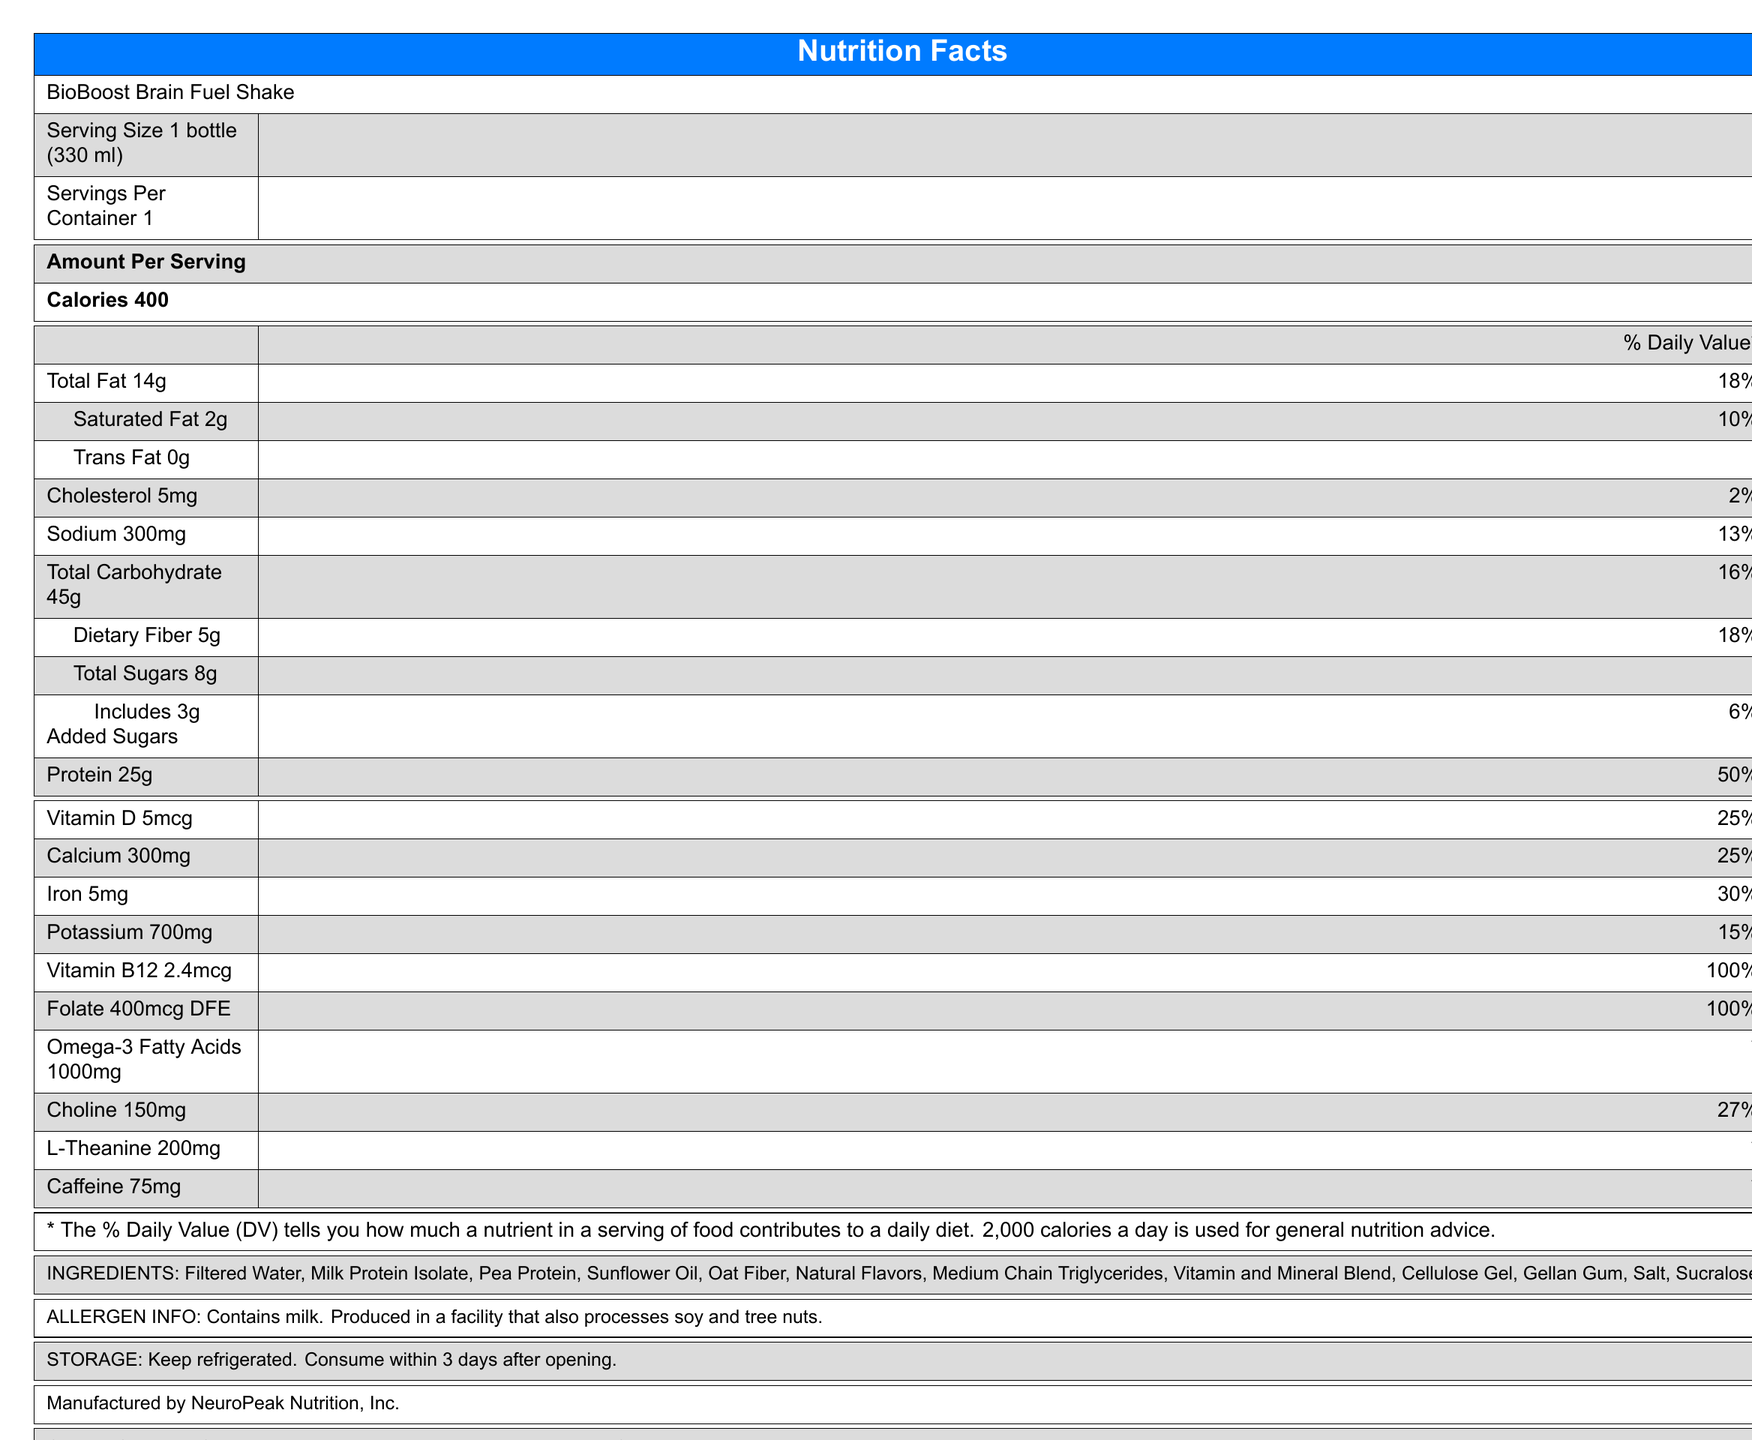what is the serving size of the BioBoost Brain Fuel Shake? The serving size is explicitly stated as "1 bottle (330 ml)" in the document.
Answer: 1 bottle (330 ml) how many calories are there per serving? The document lists the calories per serving as 400.
Answer: 400 what percentage of the daily value of protein does one serving provide? The document shows that one serving provides 25g of protein, which is 50% of the daily value.
Answer: 50% how much total carbohydrate is in one serving of the shake? The total carbohydrate per serving is listed as 45g in the document.
Answer: 45g what vitamins and minerals are provided at 100% daily value in one serving? Both Vitamin B12 and Folate are listed at 100% of the daily value for each serving.
Answer: Vitamin B12 and Folate how much sodium does one serving contain? The document states the sodium content as 300mg per serving.
Answer: 300mg how much added sugar is included in one serving of the shake? The document indicates that the shake includes 3g of added sugars per serving.
Answer: 3g which ingredient is listed first in the ingredient list? The first ingredient listed for the shake is Filtered Water.
Answer: Filtered Water where is the BioBoost Brain Fuel Shake manufactured? a) NeuroPeak Nutrition, Inc. b) BioBoost Nutrition, Inc. c) BrainFuel Co. The document specifies that the shake is manufactured by NeuroPeak Nutrition, Inc.
Answer: a) NeuroPeak Nutrition, Inc. how many grams of dietary fiber are in each serving? The dietary fiber content per serving is listed as 5g in the document.
Answer: 5g what percentage of the daily value of choline does one serving provide? The document states that one serving provides 150mg of choline, which is 27% of the daily value.
Answer: 27% does the BioBoost Brain Fuel Shake contain any allergens? The document notes that the shake contains milk and is produced in a facility that also processes soy and tree nuts.
Answer: Yes is the shake free of trans fats? The document lists the trans fat content as 0g, indicating that it is trans fat-free.
Answer: Yes how should the shake be stored once opened? The storage instructions specified in the document are to keep the shake refrigerated and consume it within 3 days after opening.
Answer: Keep refrigerated. Consume within 3 days after opening. does the shake provide omega-3 fatty acids? The document lists 1000mg of omega-3 fatty acids per serving.
Answer: Yes how much caffeine does each serving contain? The caffeine content per serving is listed as 75mg in the document.
Answer: 75mg which ingredient is not listed in the nutrition facts label but is mentioned in the additional information section? The document doesn't provide any additional ingredients beyond those already listed.
Answer: This cannot be determined. describe the main purpose of the BioBoost Brain Fuel Shake as stated in the document. The shake is described as being specially formulated for biomedical engineering students to enhance cognitive function and provide lasting energy for study and lab work.
Answer: Specially formulated for biomedical engineering students to support cognitive function and provide sustained energy during long study sessions and lab work. 